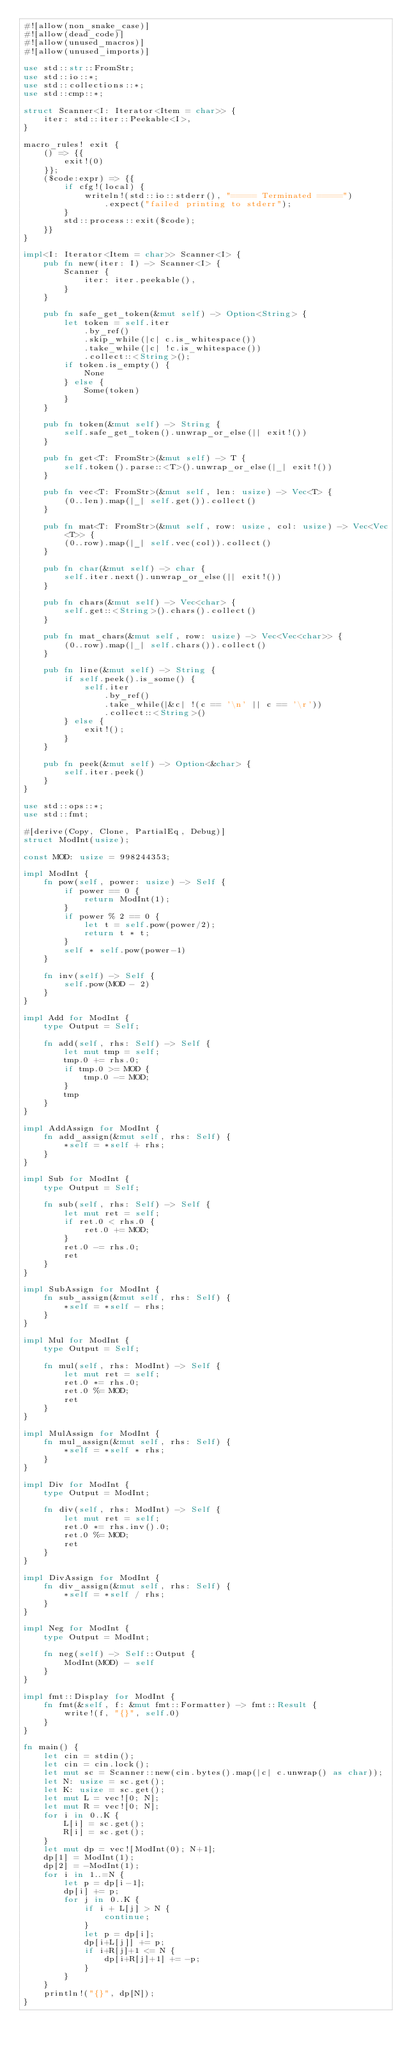<code> <loc_0><loc_0><loc_500><loc_500><_Rust_>#![allow(non_snake_case)]
#![allow(dead_code)]
#![allow(unused_macros)]
#![allow(unused_imports)]

use std::str::FromStr;
use std::io::*;
use std::collections::*;
use std::cmp::*;

struct Scanner<I: Iterator<Item = char>> {
    iter: std::iter::Peekable<I>,
}

macro_rules! exit {
    () => {{
        exit!(0)
    }};
    ($code:expr) => {{
        if cfg!(local) {
            writeln!(std::io::stderr(), "===== Terminated =====")
                .expect("failed printing to stderr");
        }
        std::process::exit($code);
    }}
}

impl<I: Iterator<Item = char>> Scanner<I> {
    pub fn new(iter: I) -> Scanner<I> {
        Scanner {
            iter: iter.peekable(),
        }
    }

    pub fn safe_get_token(&mut self) -> Option<String> {
        let token = self.iter
            .by_ref()
            .skip_while(|c| c.is_whitespace())
            .take_while(|c| !c.is_whitespace())
            .collect::<String>();
        if token.is_empty() {
            None
        } else {
            Some(token)
        }
    }

    pub fn token(&mut self) -> String {
        self.safe_get_token().unwrap_or_else(|| exit!())
    }

    pub fn get<T: FromStr>(&mut self) -> T {
        self.token().parse::<T>().unwrap_or_else(|_| exit!())
    }

    pub fn vec<T: FromStr>(&mut self, len: usize) -> Vec<T> {
        (0..len).map(|_| self.get()).collect()
    }

    pub fn mat<T: FromStr>(&mut self, row: usize, col: usize) -> Vec<Vec<T>> {
        (0..row).map(|_| self.vec(col)).collect()
    }

    pub fn char(&mut self) -> char {
        self.iter.next().unwrap_or_else(|| exit!())
    }

    pub fn chars(&mut self) -> Vec<char> {
        self.get::<String>().chars().collect()
    }

    pub fn mat_chars(&mut self, row: usize) -> Vec<Vec<char>> {
        (0..row).map(|_| self.chars()).collect()
    }

    pub fn line(&mut self) -> String {
        if self.peek().is_some() {
            self.iter
                .by_ref()
                .take_while(|&c| !(c == '\n' || c == '\r'))
                .collect::<String>()
        } else {
            exit!();
        }
    }

    pub fn peek(&mut self) -> Option<&char> {
        self.iter.peek()
    }
}

use std::ops::*;
use std::fmt;

#[derive(Copy, Clone, PartialEq, Debug)]
struct ModInt(usize);

const MOD: usize = 998244353;

impl ModInt {
    fn pow(self, power: usize) -> Self {
        if power == 0 {
            return ModInt(1);
        }
        if power % 2 == 0 {
            let t = self.pow(power/2);
            return t * t;
        }
        self * self.pow(power-1)
    }

    fn inv(self) -> Self {
        self.pow(MOD - 2)
    }
}

impl Add for ModInt {
    type Output = Self;

    fn add(self, rhs: Self) -> Self {
        let mut tmp = self;
        tmp.0 += rhs.0;
        if tmp.0 >= MOD {
            tmp.0 -= MOD;
        }
        tmp
    }
}

impl AddAssign for ModInt {
    fn add_assign(&mut self, rhs: Self) {
        *self = *self + rhs;
    }
}

impl Sub for ModInt {
    type Output = Self;

    fn sub(self, rhs: Self) -> Self {
        let mut ret = self;
        if ret.0 < rhs.0 {
            ret.0 += MOD;
        }
        ret.0 -= rhs.0;
        ret
    }
}

impl SubAssign for ModInt {
    fn sub_assign(&mut self, rhs: Self) {
        *self = *self - rhs;
    }
}

impl Mul for ModInt {
    type Output = Self;

    fn mul(self, rhs: ModInt) -> Self {
        let mut ret = self;
        ret.0 *= rhs.0;
        ret.0 %= MOD;
        ret
    }
}

impl MulAssign for ModInt {
    fn mul_assign(&mut self, rhs: Self) {
        *self = *self * rhs;
    }
}

impl Div for ModInt {
    type Output = ModInt;

    fn div(self, rhs: ModInt) -> Self {
        let mut ret = self;
        ret.0 *= rhs.inv().0;
        ret.0 %= MOD;
        ret
    }
}

impl DivAssign for ModInt {
    fn div_assign(&mut self, rhs: Self) {
        *self = *self / rhs;
    }
}

impl Neg for ModInt {
    type Output = ModInt;
 
    fn neg(self) -> Self::Output {
        ModInt(MOD) - self
    }
}

impl fmt::Display for ModInt {
    fn fmt(&self, f: &mut fmt::Formatter) -> fmt::Result {
        write!(f, "{}", self.0)
    }
}

fn main() {
    let cin = stdin();
    let cin = cin.lock();
    let mut sc = Scanner::new(cin.bytes().map(|c| c.unwrap() as char));
    let N: usize = sc.get();
    let K: usize = sc.get();
    let mut L = vec![0; N];
    let mut R = vec![0; N];
    for i in 0..K {
        L[i] = sc.get();
        R[i] = sc.get();
    }
    let mut dp = vec![ModInt(0); N+1];
    dp[1] = ModInt(1);
    dp[2] = -ModInt(1);
    for i in 1..=N {
        let p = dp[i-1];
        dp[i] += p;
        for j in 0..K {
            if i + L[j] > N {
                continue;
            }
            let p = dp[i];
            dp[i+L[j]] += p;
            if i+R[j]+1 <= N {
                dp[i+R[j]+1] += -p;
            }
        }
    }
    println!("{}", dp[N]);
}
</code> 